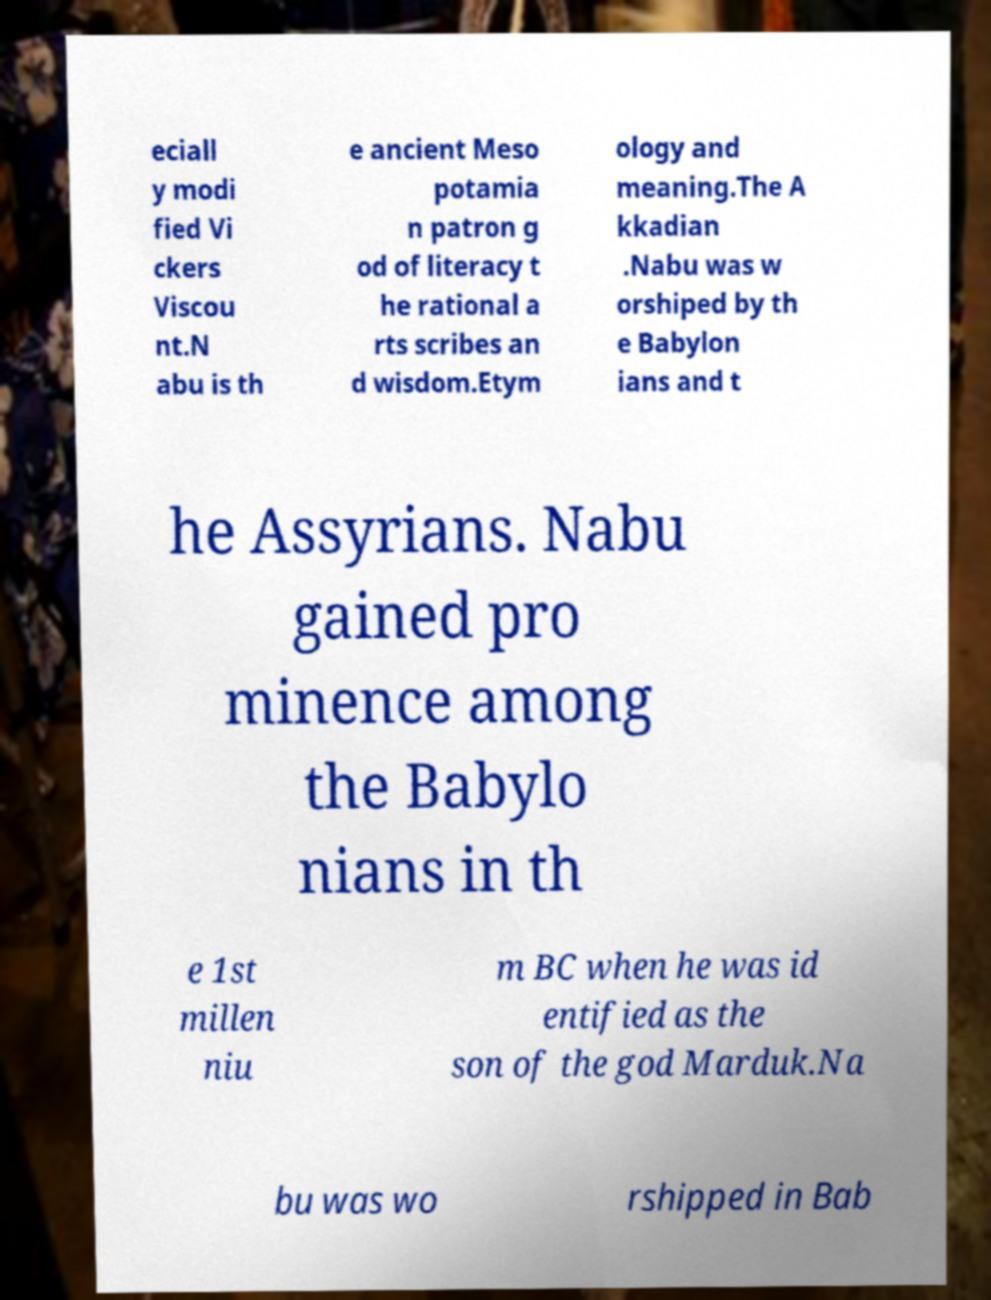Can you read and provide the text displayed in the image?This photo seems to have some interesting text. Can you extract and type it out for me? eciall y modi fied Vi ckers Viscou nt.N abu is th e ancient Meso potamia n patron g od of literacy t he rational a rts scribes an d wisdom.Etym ology and meaning.The A kkadian .Nabu was w orshiped by th e Babylon ians and t he Assyrians. Nabu gained pro minence among the Babylo nians in th e 1st millen niu m BC when he was id entified as the son of the god Marduk.Na bu was wo rshipped in Bab 